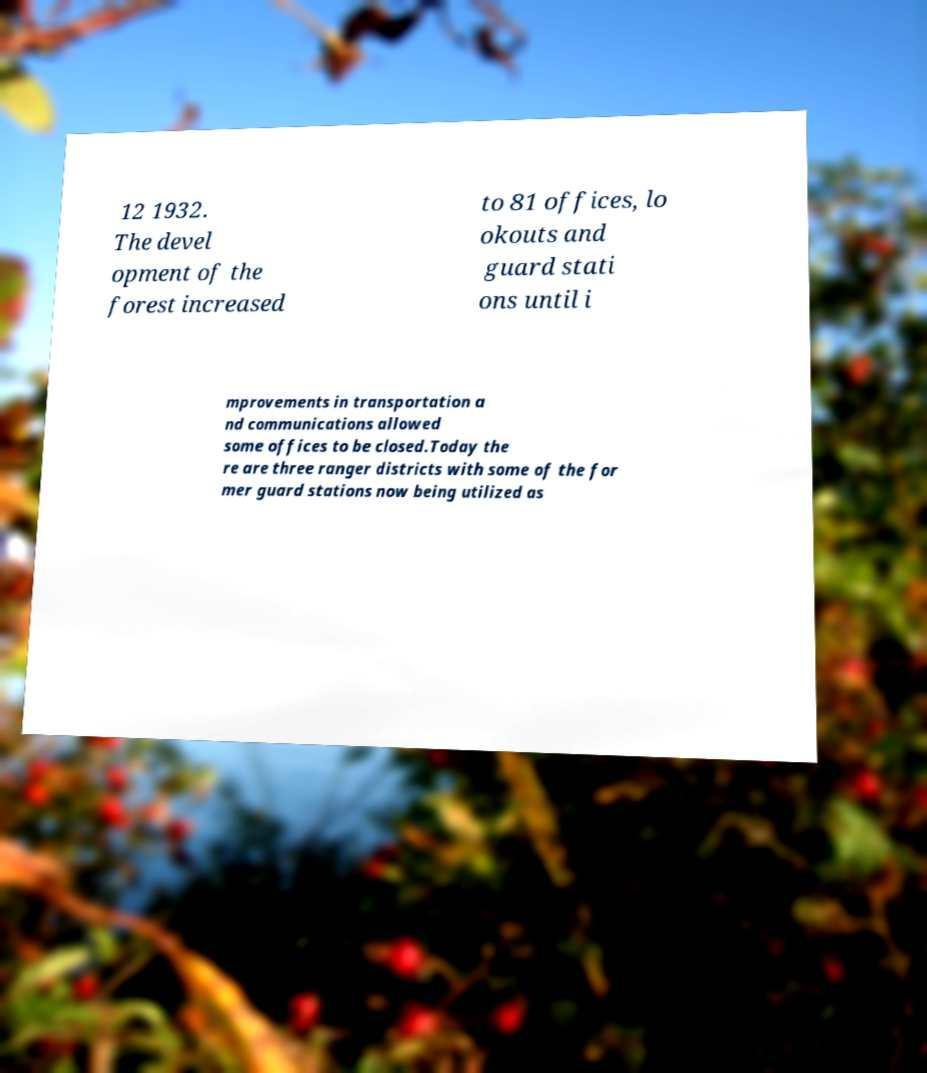I need the written content from this picture converted into text. Can you do that? 12 1932. The devel opment of the forest increased to 81 offices, lo okouts and guard stati ons until i mprovements in transportation a nd communications allowed some offices to be closed.Today the re are three ranger districts with some of the for mer guard stations now being utilized as 